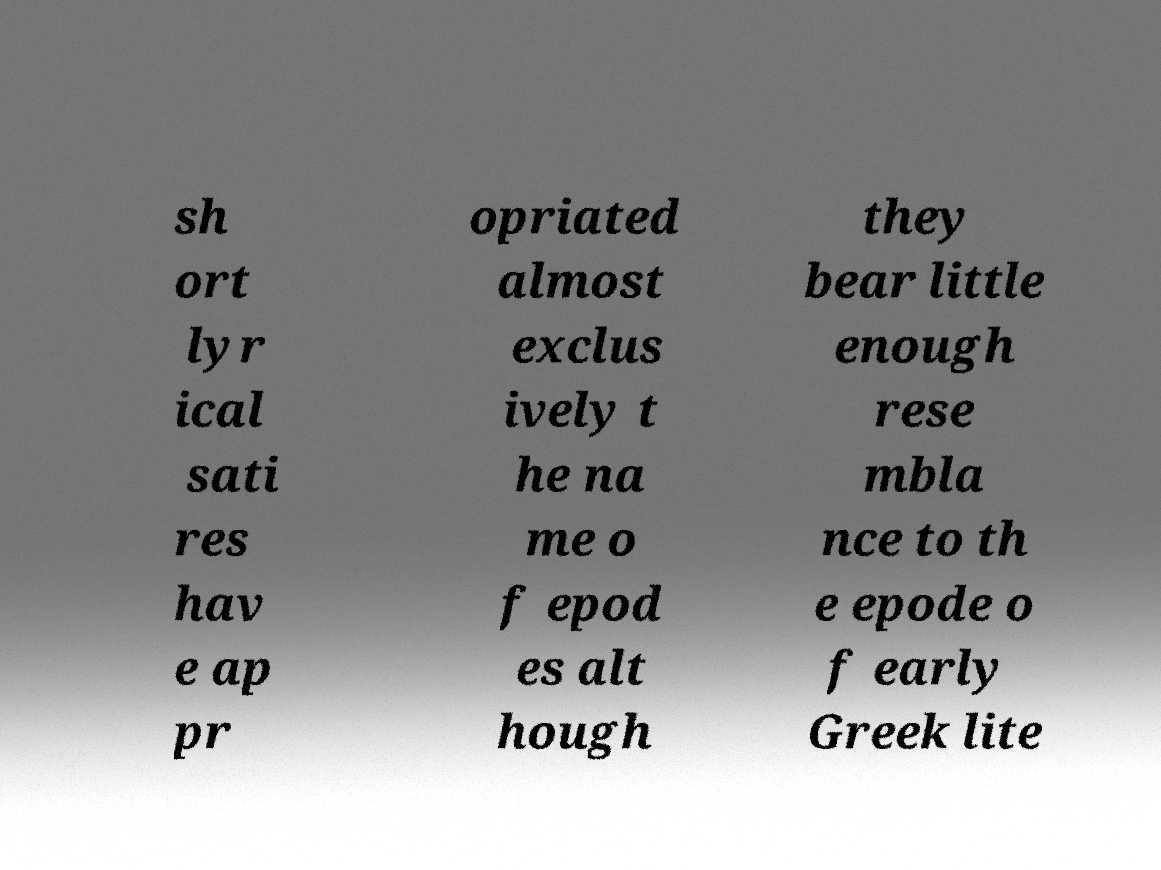Can you read and provide the text displayed in the image?This photo seems to have some interesting text. Can you extract and type it out for me? sh ort lyr ical sati res hav e ap pr opriated almost exclus ively t he na me o f epod es alt hough they bear little enough rese mbla nce to th e epode o f early Greek lite 